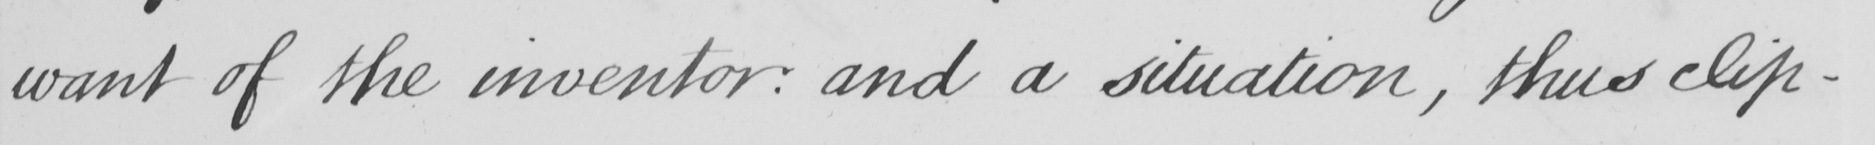Can you tell me what this handwritten text says? want of the inventory :  and a situation , this clip- 